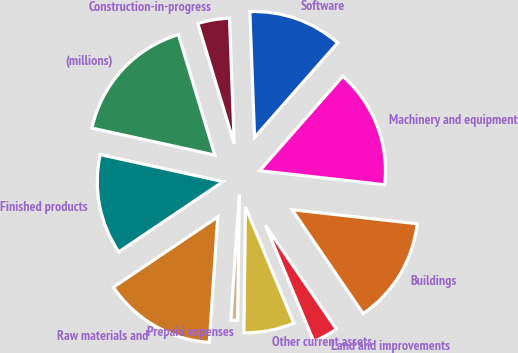<chart> <loc_0><loc_0><loc_500><loc_500><pie_chart><fcel>(millions)<fcel>Finished products<fcel>Raw materials and<fcel>Prepaid expenses<fcel>Other current assets<fcel>Land and improvements<fcel>Buildings<fcel>Machinery and equipment<fcel>Software<fcel>Construction-in-progress<nl><fcel>16.89%<fcel>12.88%<fcel>14.48%<fcel>0.87%<fcel>6.48%<fcel>3.27%<fcel>13.68%<fcel>15.29%<fcel>12.08%<fcel>4.07%<nl></chart> 